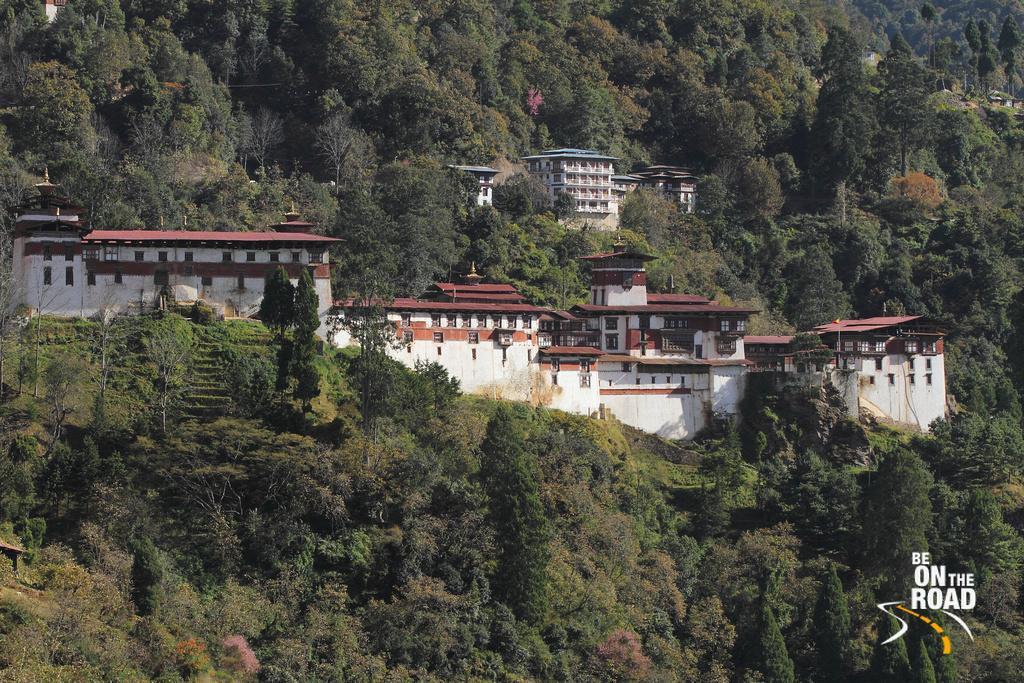Describe this image in one or two sentences. In this picture I can see the buildings. I can see trees. 